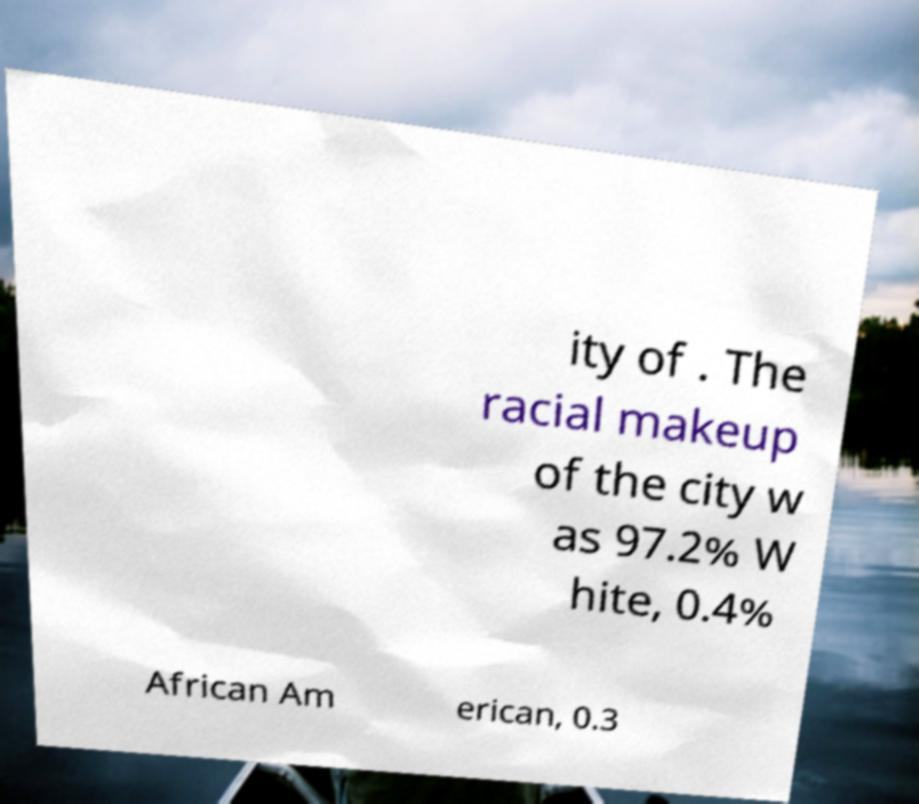There's text embedded in this image that I need extracted. Can you transcribe it verbatim? ity of . The racial makeup of the city w as 97.2% W hite, 0.4% African Am erican, 0.3 